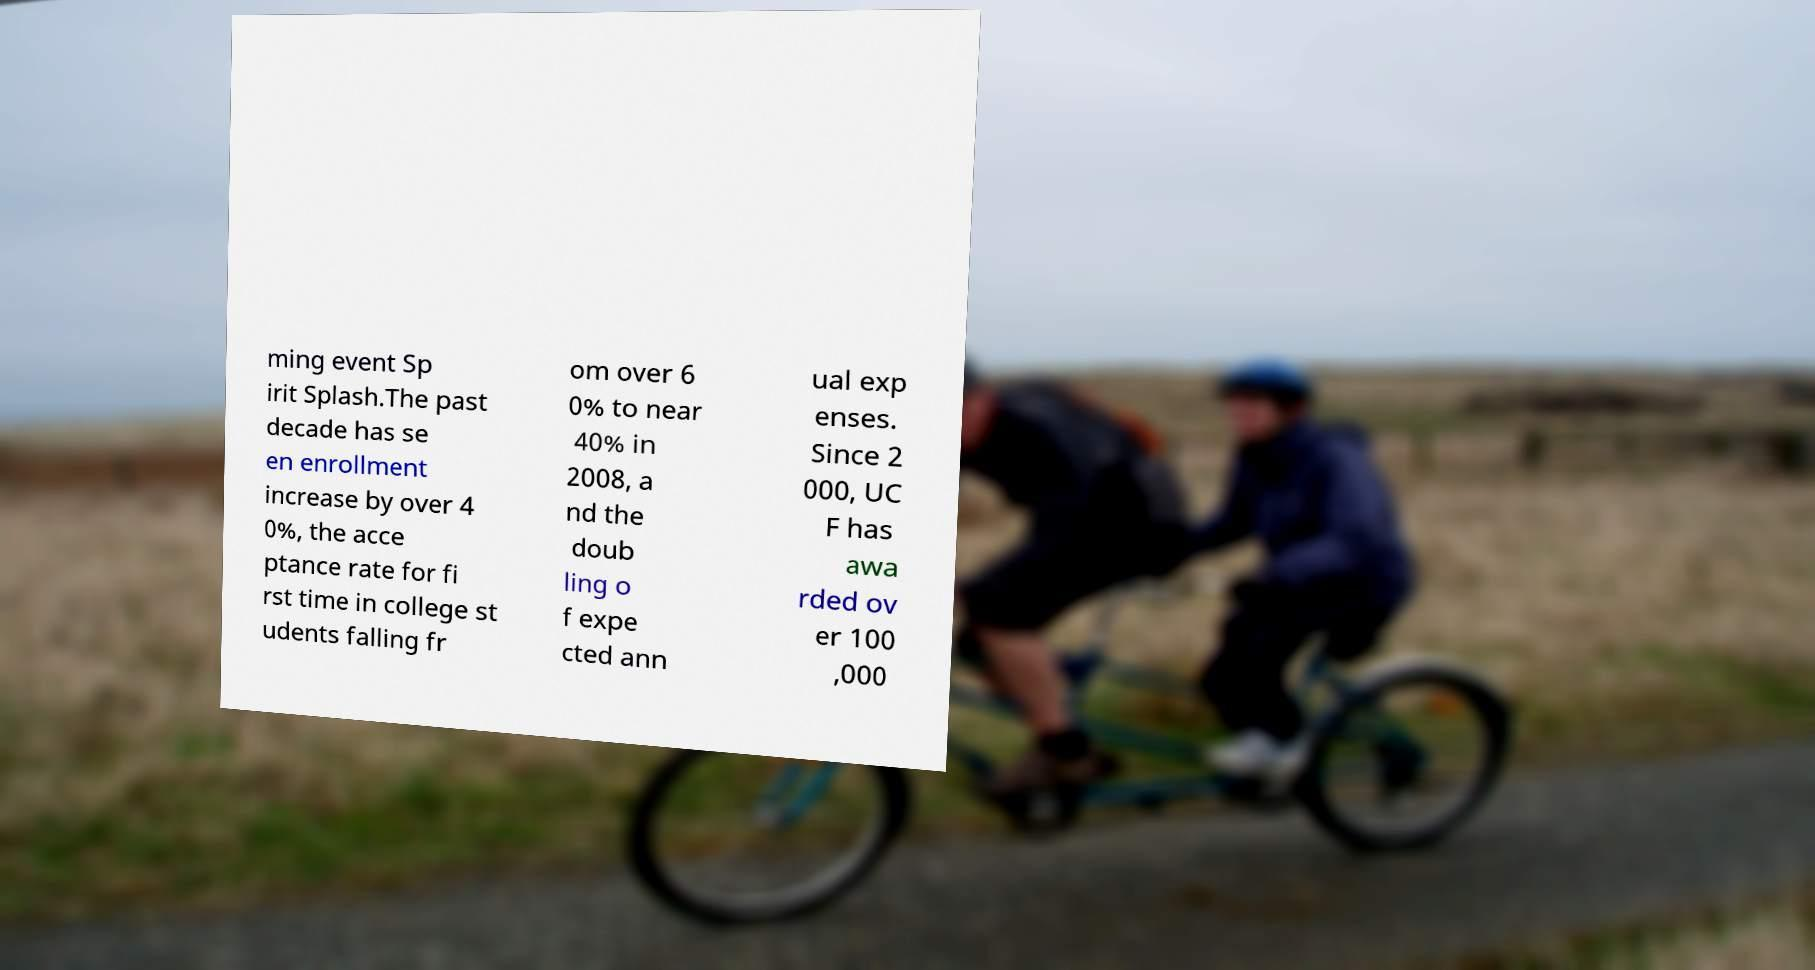Please read and relay the text visible in this image. What does it say? ming event Sp irit Splash.The past decade has se en enrollment increase by over 4 0%, the acce ptance rate for fi rst time in college st udents falling fr om over 6 0% to near 40% in 2008, a nd the doub ling o f expe cted ann ual exp enses. Since 2 000, UC F has awa rded ov er 100 ,000 